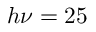Convert formula to latex. <formula><loc_0><loc_0><loc_500><loc_500>h \nu = 2 5</formula> 